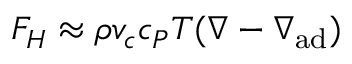<formula> <loc_0><loc_0><loc_500><loc_500>F _ { H } \approx \rho v _ { c } c _ { P } T ( \nabla - \nabla _ { a d } )</formula> 